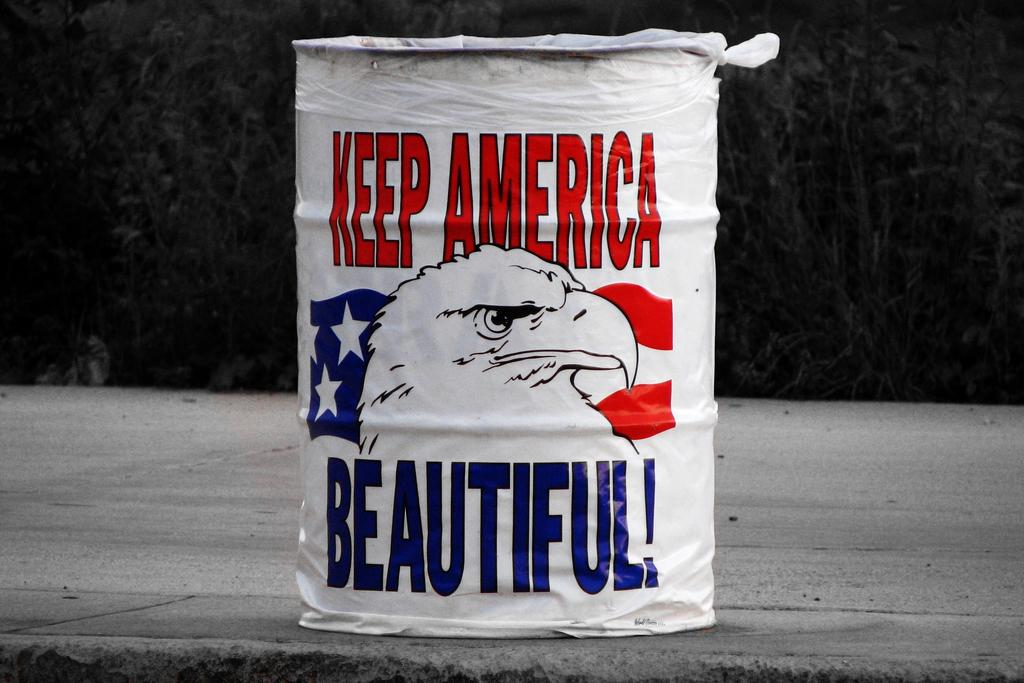Provide a one-sentence caption for the provided image. Garbage can painted with Keep America Beautiful on it. 